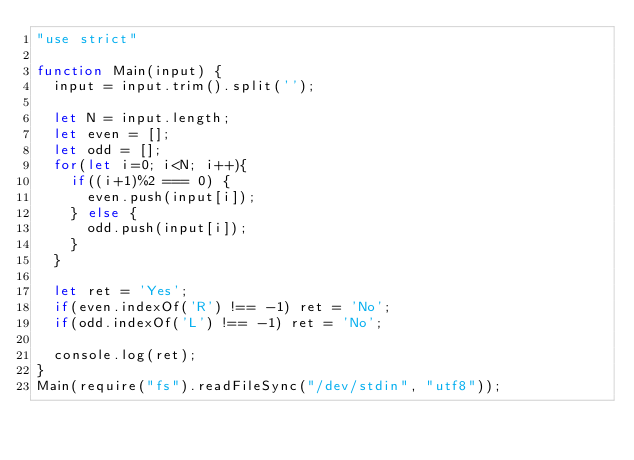<code> <loc_0><loc_0><loc_500><loc_500><_JavaScript_>"use strict"

function Main(input) {
  input = input.trim().split('');

  let N = input.length;
  let even = [];
  let odd = [];
  for(let i=0; i<N; i++){
    if((i+1)%2 === 0) {
      even.push(input[i]);
    } else {
      odd.push(input[i]);
    }
  }
  
  let ret = 'Yes';
  if(even.indexOf('R') !== -1) ret = 'No';
  if(odd.indexOf('L') !== -1) ret = 'No';

  console.log(ret);
}
Main(require("fs").readFileSync("/dev/stdin", "utf8"));</code> 